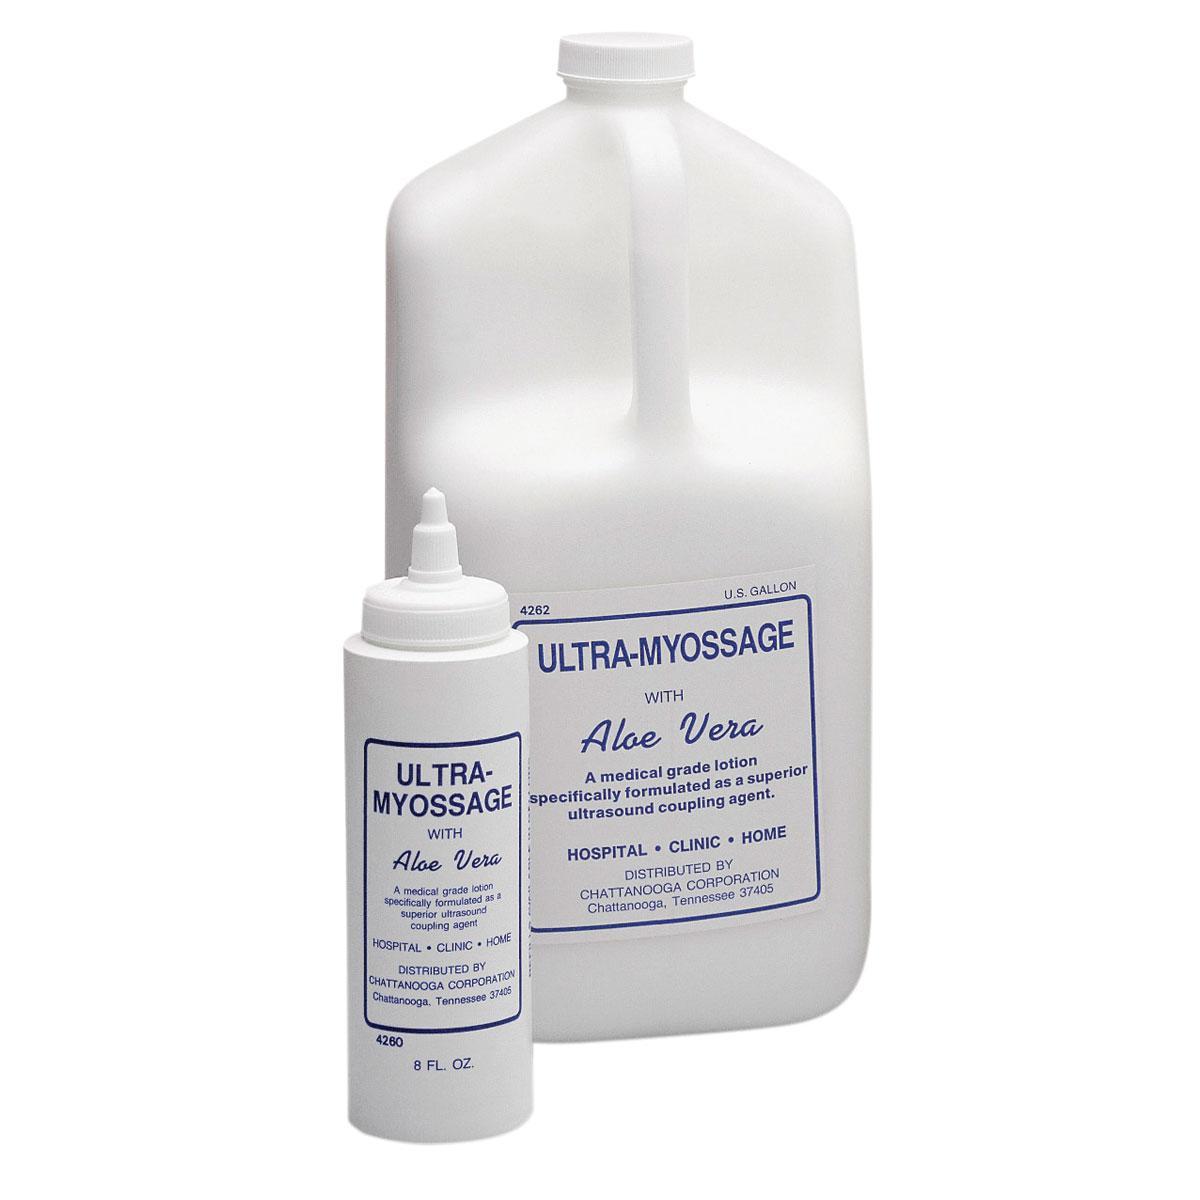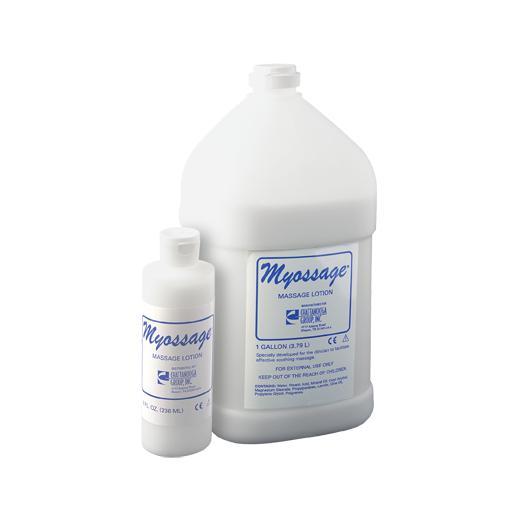The first image is the image on the left, the second image is the image on the right. For the images shown, is this caption "At least one image only has one bottle." true? Answer yes or no. No. 